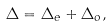Convert formula to latex. <formula><loc_0><loc_0><loc_500><loc_500>\Delta = \Delta _ { e } + \Delta _ { o } ,</formula> 